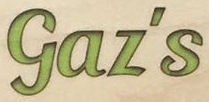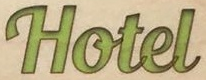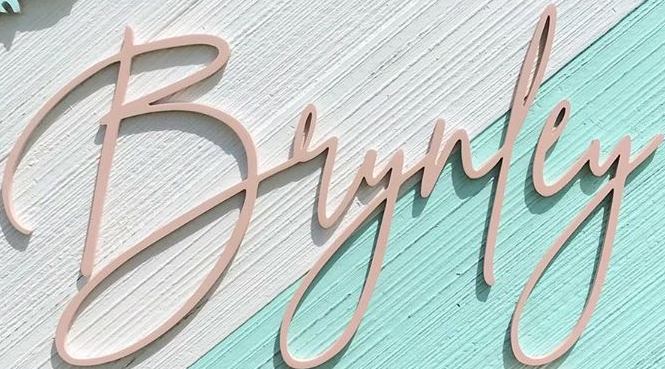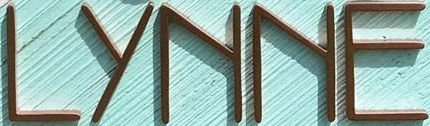Read the text from these images in sequence, separated by a semicolon. Gaz's; Hotel; Brynley; LYNNE 